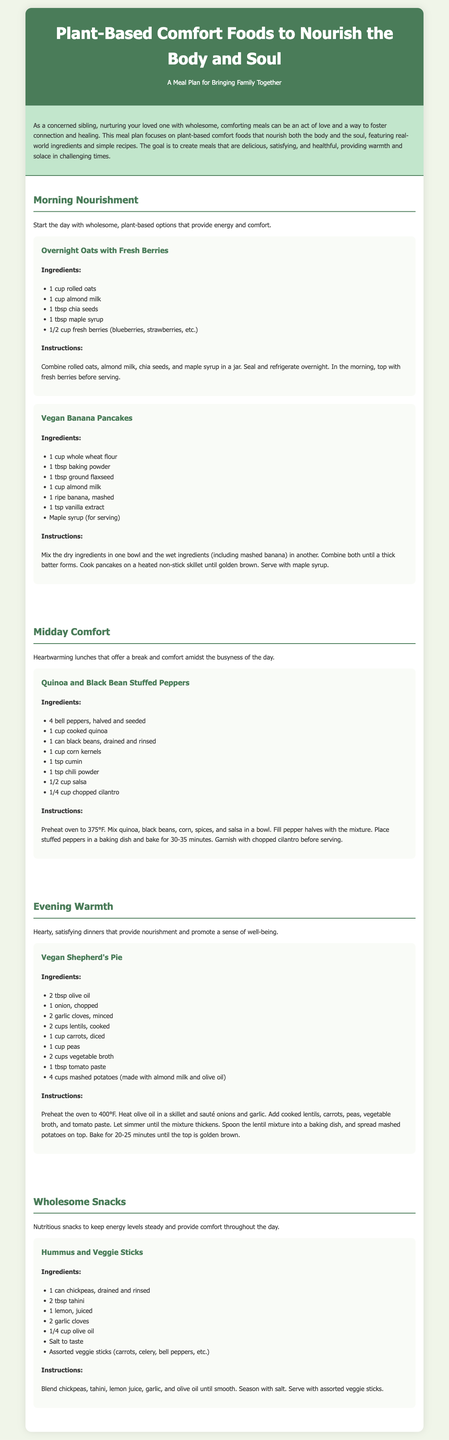what are the two breakfast recipes mentioned? The document lists "Overnight Oats with Fresh Berries" and "Vegan Banana Pancakes" as the breakfast recipes.
Answer: Overnight Oats with Fresh Berries, Vegan Banana Pancakes how many ingredients are in the Vegan Shepherd's Pie recipe? The Vegan Shepherd's Pie recipe includes 10 ingredients as listed in the document.
Answer: 10 what is the temperature to preheat the oven for the Quinoa and Black Bean Stuffed Peppers? The document specifies to preheat the oven to 375°F for the Quinoa and Black Bean Stuffed Peppers.
Answer: 375°F what meal section is dedicated to snacks? The section for snacks is titled "Wholesome Snacks" in the meal plan.
Answer: Wholesome Snacks how long should the Vegan Shepherd's Pie be baked? The document specifies that the Vegan Shepherd's Pie should be baked for 20-25 minutes.
Answer: 20-25 minutes 